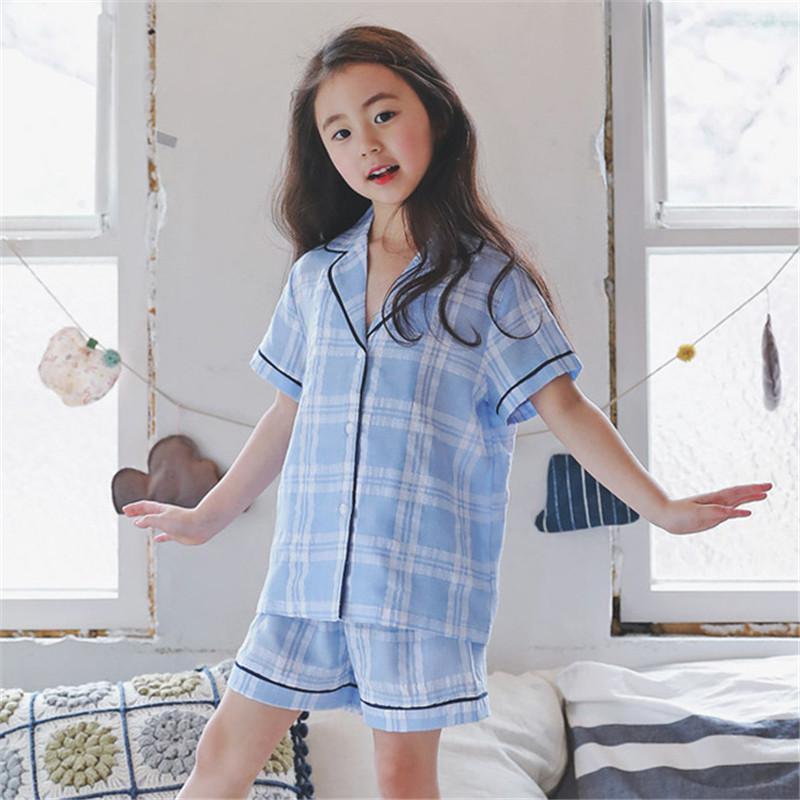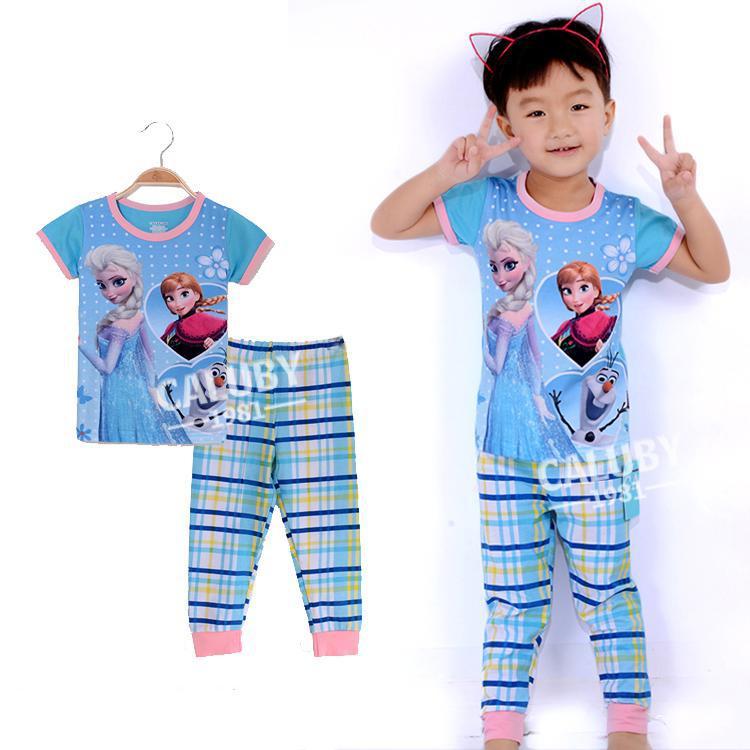The first image is the image on the left, the second image is the image on the right. For the images shown, is this caption "All images include a human model wearing a pajama set featuring plaid bottoms, and one model in matching blue top and bottom is in front of a row of pillows." true? Answer yes or no. Yes. The first image is the image on the left, the second image is the image on the right. Analyze the images presented: Is the assertion "The right image contains one person that is wearing predominately blue sleep wear." valid? Answer yes or no. Yes. 